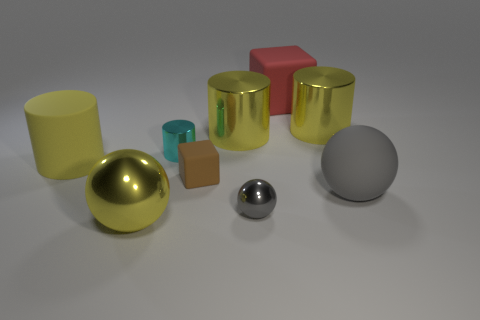Subtract all big yellow rubber cylinders. How many cylinders are left? 3 Add 1 small rubber objects. How many objects exist? 10 Subtract all green balls. How many cyan cylinders are left? 1 Subtract all small cyan cylinders. Subtract all large matte objects. How many objects are left? 5 Add 6 tiny gray metallic things. How many tiny gray metallic things are left? 7 Add 2 brown rubber things. How many brown rubber things exist? 3 Subtract all red blocks. How many blocks are left? 1 Subtract 0 red spheres. How many objects are left? 9 Subtract all cylinders. How many objects are left? 5 Subtract all purple spheres. Subtract all brown blocks. How many spheres are left? 3 